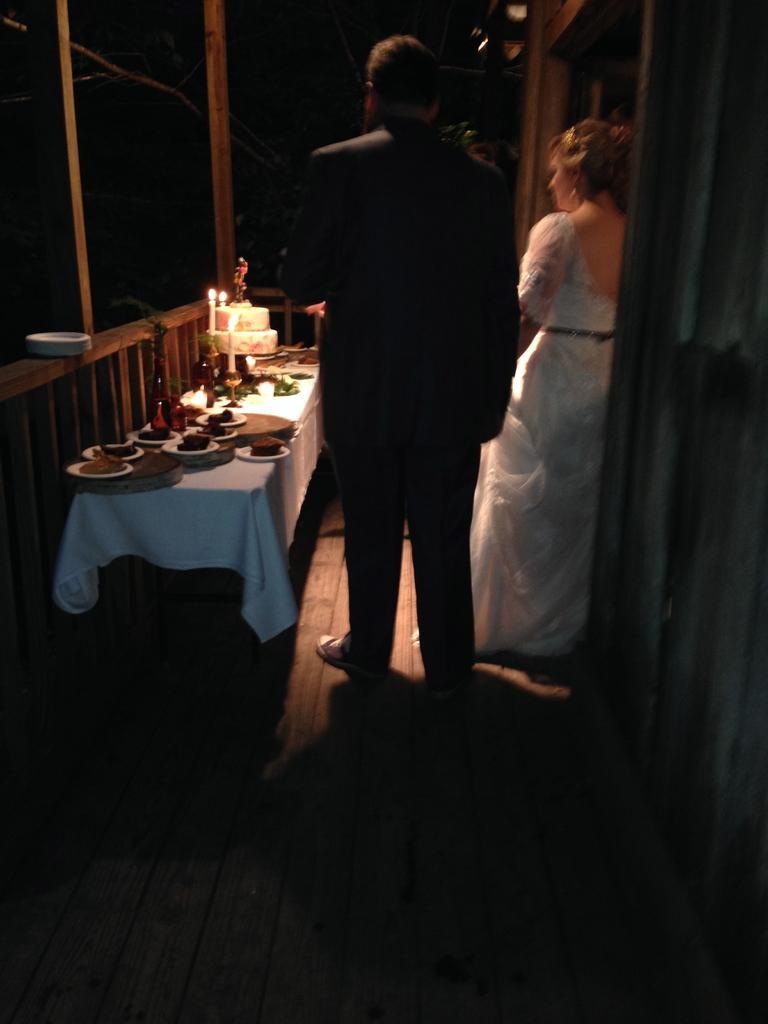Could you give a brief overview of what you see in this image? In this image the two person standing. On the table there is a plate,food,cake,candle. 